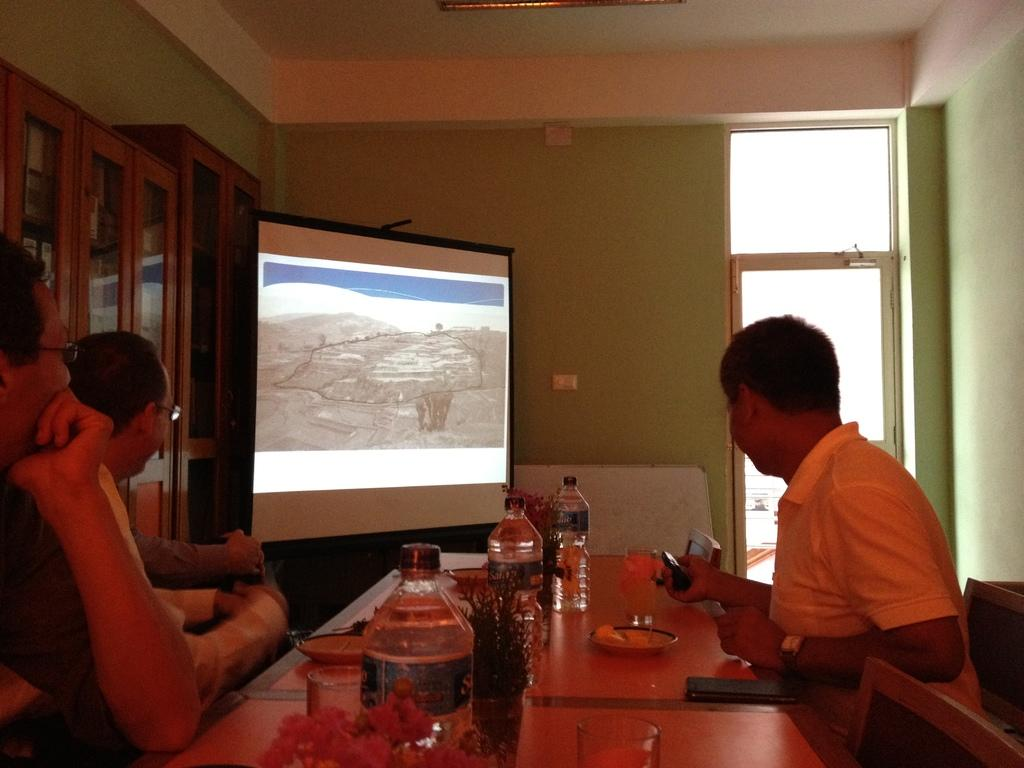What are the persons in the image doing? The persons in the image are sitting in chairs. What is in front of the persons? There is a table in front of the persons. What can be found on the table? The table has eatables and drinks on it. What is being projected in front of the persons? There is a projected image in front of the persons. What type of skin condition can be seen on the persons in the image? There is no indication of any skin condition on the persons in the image. What is the cause of the projected image in the image? The cause of the projected image is not visible or mentioned in the image, so it cannot be determined. 